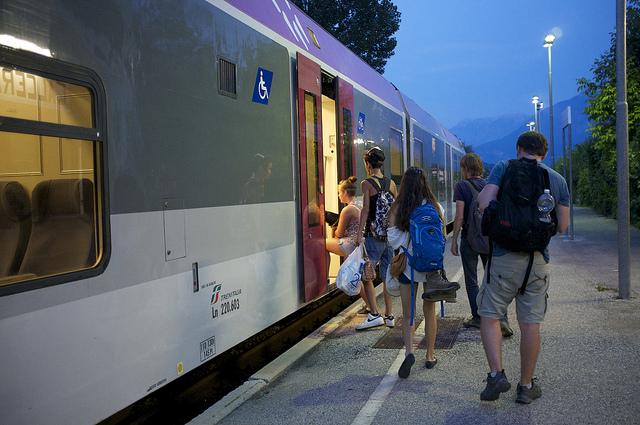How many people are on the train platform?
Concise answer only. 5. Are the passengers boarding or deboarding?
Write a very short answer. Boarding. What type of vehicle are the people boarding?
Concise answer only. Train. What is the boy doing?
Quick response, please. Boarding train. What color bag is the man holding?
Short answer required. Black. Is the sun on the left or right side of this photo?
Write a very short answer. Right. Are the street lights on?
Write a very short answer. Yes. What is the weather like?
Keep it brief. Clear. What is the profession of the man standing in the door?
Keep it brief. Student. How many people are on the stairs?
Keep it brief. 1. 